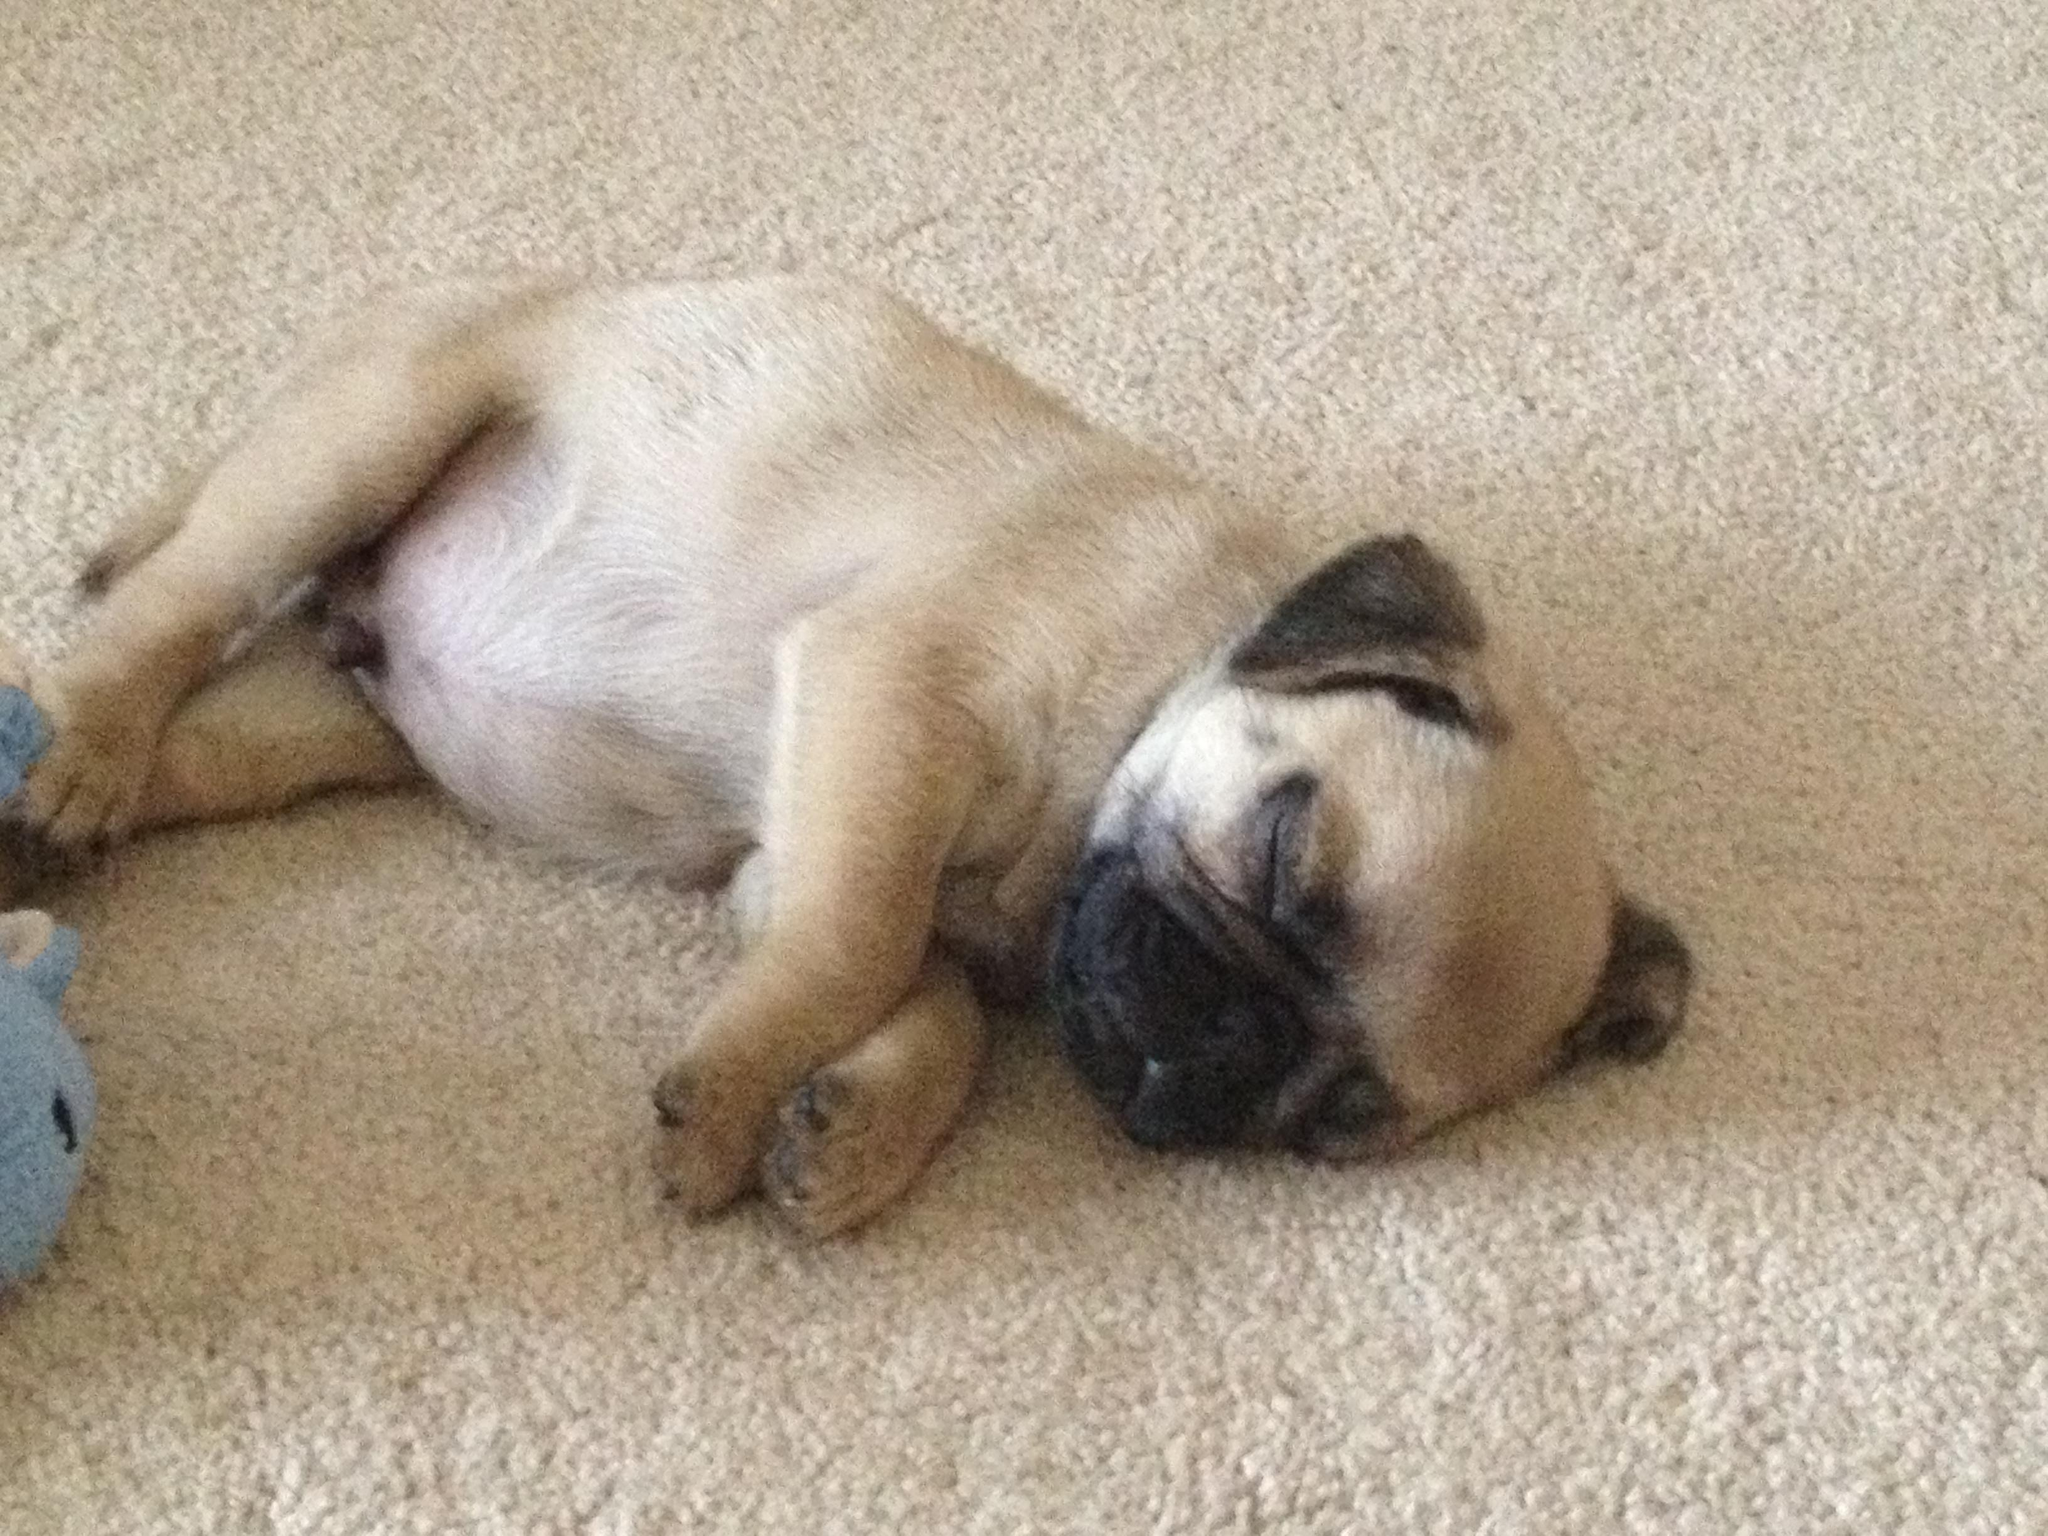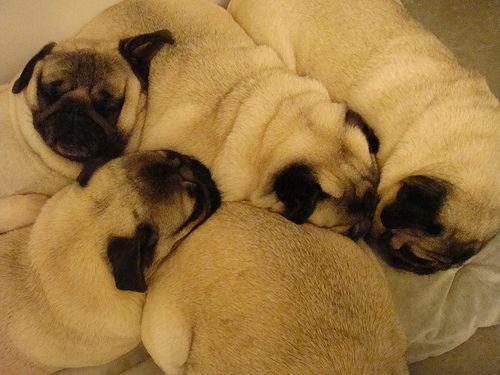The first image is the image on the left, the second image is the image on the right. Examine the images to the left and right. Is the description "There are more pug dogs in the right image than in the left." accurate? Answer yes or no. Yes. The first image is the image on the left, the second image is the image on the right. For the images displayed, is the sentence "there are no more than three puppies in the image on the left." factually correct? Answer yes or no. Yes. 